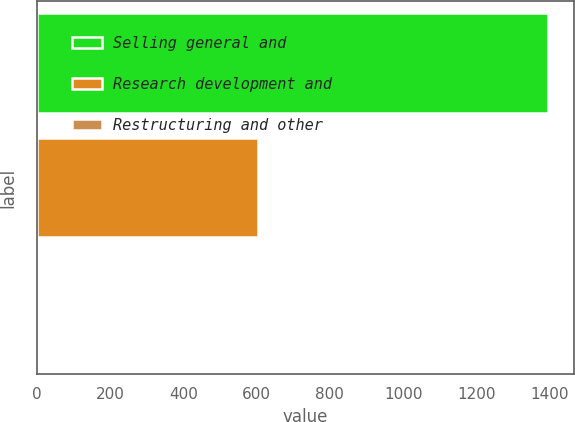Convert chart to OTSL. <chart><loc_0><loc_0><loc_500><loc_500><bar_chart><fcel>Selling general and<fcel>Research development and<fcel>Restructuring and other<nl><fcel>1396<fcel>603<fcel>2<nl></chart> 